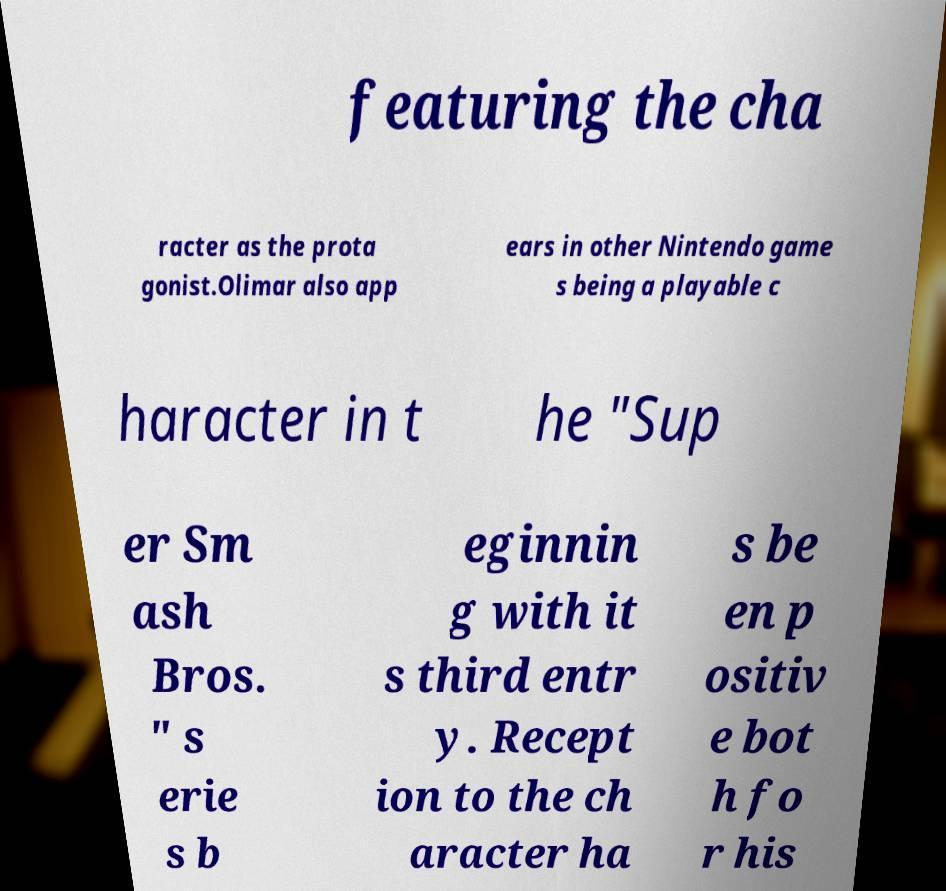Can you read and provide the text displayed in the image?This photo seems to have some interesting text. Can you extract and type it out for me? featuring the cha racter as the prota gonist.Olimar also app ears in other Nintendo game s being a playable c haracter in t he "Sup er Sm ash Bros. " s erie s b eginnin g with it s third entr y. Recept ion to the ch aracter ha s be en p ositiv e bot h fo r his 